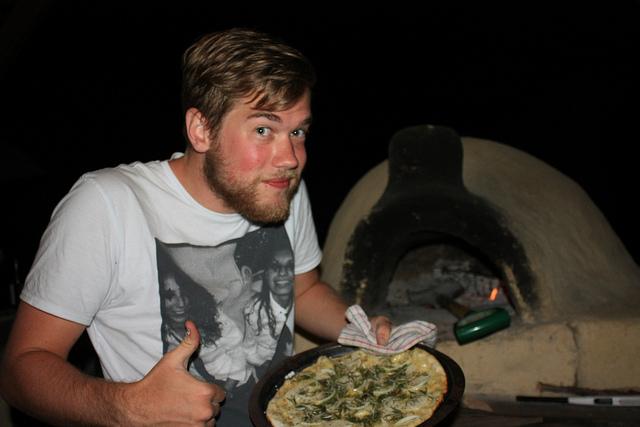What is the age of this man?
Answer briefly. 28. What is on the man's pizza?
Concise answer only. Onions. What kind of oven was used to cook the pizza?
Short answer required. Stone. What is the man holding?
Answer briefly. Pizza. What food is shown?
Give a very brief answer. Pizza. What color is the man's beard?
Give a very brief answer. Brown. What is the man eating?
Short answer required. Pizza. What is in the oven?
Write a very short answer. Shovel. 